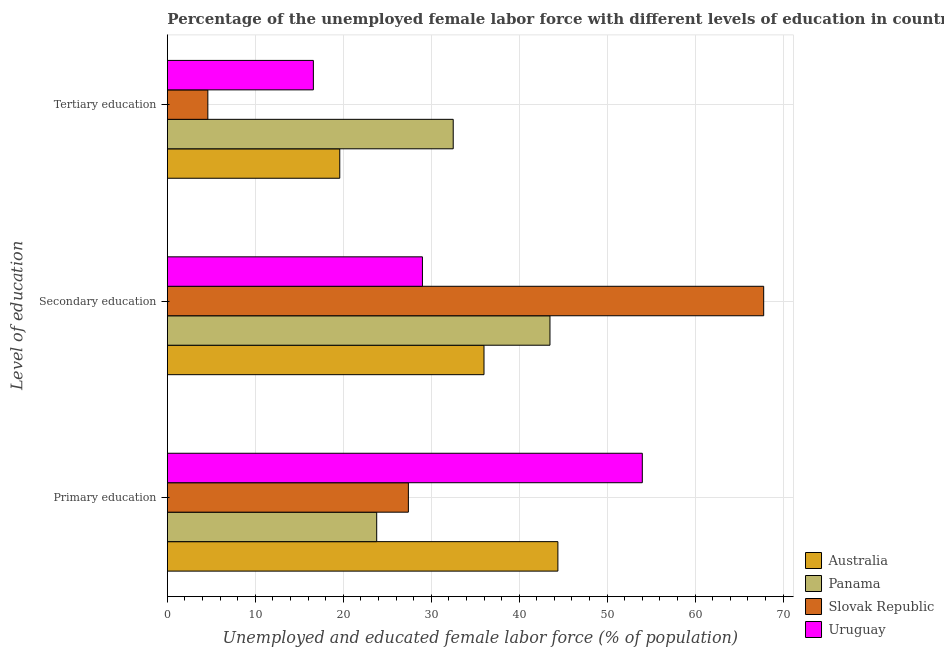How many groups of bars are there?
Offer a very short reply. 3. What is the label of the 2nd group of bars from the top?
Provide a short and direct response. Secondary education. What is the percentage of female labor force who received primary education in Australia?
Keep it short and to the point. 44.4. Across all countries, what is the maximum percentage of female labor force who received secondary education?
Give a very brief answer. 67.8. Across all countries, what is the minimum percentage of female labor force who received secondary education?
Give a very brief answer. 29. In which country was the percentage of female labor force who received secondary education maximum?
Offer a terse response. Slovak Republic. In which country was the percentage of female labor force who received tertiary education minimum?
Your answer should be very brief. Slovak Republic. What is the total percentage of female labor force who received tertiary education in the graph?
Provide a short and direct response. 73.3. What is the difference between the percentage of female labor force who received secondary education in Panama and that in Slovak Republic?
Your answer should be very brief. -24.3. What is the difference between the percentage of female labor force who received secondary education in Panama and the percentage of female labor force who received primary education in Slovak Republic?
Keep it short and to the point. 16.1. What is the average percentage of female labor force who received primary education per country?
Ensure brevity in your answer.  37.4. What is the ratio of the percentage of female labor force who received secondary education in Australia to that in Uruguay?
Give a very brief answer. 1.24. Is the percentage of female labor force who received tertiary education in Slovak Republic less than that in Australia?
Your answer should be compact. Yes. Is the difference between the percentage of female labor force who received tertiary education in Panama and Uruguay greater than the difference between the percentage of female labor force who received primary education in Panama and Uruguay?
Offer a terse response. Yes. What is the difference between the highest and the second highest percentage of female labor force who received tertiary education?
Give a very brief answer. 12.9. What is the difference between the highest and the lowest percentage of female labor force who received tertiary education?
Provide a short and direct response. 27.9. In how many countries, is the percentage of female labor force who received secondary education greater than the average percentage of female labor force who received secondary education taken over all countries?
Offer a terse response. 1. What does the 4th bar from the top in Tertiary education represents?
Offer a terse response. Australia. What does the 2nd bar from the bottom in Tertiary education represents?
Ensure brevity in your answer.  Panama. What is the difference between two consecutive major ticks on the X-axis?
Your answer should be very brief. 10. Are the values on the major ticks of X-axis written in scientific E-notation?
Your answer should be compact. No. Does the graph contain any zero values?
Your response must be concise. No. How many legend labels are there?
Provide a short and direct response. 4. How are the legend labels stacked?
Your response must be concise. Vertical. What is the title of the graph?
Keep it short and to the point. Percentage of the unemployed female labor force with different levels of education in countries. Does "Greece" appear as one of the legend labels in the graph?
Keep it short and to the point. No. What is the label or title of the X-axis?
Give a very brief answer. Unemployed and educated female labor force (% of population). What is the label or title of the Y-axis?
Offer a very short reply. Level of education. What is the Unemployed and educated female labor force (% of population) in Australia in Primary education?
Your answer should be very brief. 44.4. What is the Unemployed and educated female labor force (% of population) of Panama in Primary education?
Your answer should be very brief. 23.8. What is the Unemployed and educated female labor force (% of population) of Slovak Republic in Primary education?
Provide a short and direct response. 27.4. What is the Unemployed and educated female labor force (% of population) in Uruguay in Primary education?
Ensure brevity in your answer.  54. What is the Unemployed and educated female labor force (% of population) in Australia in Secondary education?
Your answer should be very brief. 36. What is the Unemployed and educated female labor force (% of population) of Panama in Secondary education?
Ensure brevity in your answer.  43.5. What is the Unemployed and educated female labor force (% of population) in Slovak Republic in Secondary education?
Offer a terse response. 67.8. What is the Unemployed and educated female labor force (% of population) in Australia in Tertiary education?
Ensure brevity in your answer.  19.6. What is the Unemployed and educated female labor force (% of population) in Panama in Tertiary education?
Give a very brief answer. 32.5. What is the Unemployed and educated female labor force (% of population) of Slovak Republic in Tertiary education?
Give a very brief answer. 4.6. What is the Unemployed and educated female labor force (% of population) of Uruguay in Tertiary education?
Make the answer very short. 16.6. Across all Level of education, what is the maximum Unemployed and educated female labor force (% of population) of Australia?
Your answer should be compact. 44.4. Across all Level of education, what is the maximum Unemployed and educated female labor force (% of population) of Panama?
Ensure brevity in your answer.  43.5. Across all Level of education, what is the maximum Unemployed and educated female labor force (% of population) of Slovak Republic?
Your answer should be compact. 67.8. Across all Level of education, what is the maximum Unemployed and educated female labor force (% of population) of Uruguay?
Provide a succinct answer. 54. Across all Level of education, what is the minimum Unemployed and educated female labor force (% of population) in Australia?
Offer a terse response. 19.6. Across all Level of education, what is the minimum Unemployed and educated female labor force (% of population) of Panama?
Your response must be concise. 23.8. Across all Level of education, what is the minimum Unemployed and educated female labor force (% of population) of Slovak Republic?
Keep it short and to the point. 4.6. Across all Level of education, what is the minimum Unemployed and educated female labor force (% of population) in Uruguay?
Your answer should be compact. 16.6. What is the total Unemployed and educated female labor force (% of population) in Australia in the graph?
Provide a short and direct response. 100. What is the total Unemployed and educated female labor force (% of population) in Panama in the graph?
Offer a very short reply. 99.8. What is the total Unemployed and educated female labor force (% of population) in Slovak Republic in the graph?
Provide a succinct answer. 99.8. What is the total Unemployed and educated female labor force (% of population) in Uruguay in the graph?
Your answer should be compact. 99.6. What is the difference between the Unemployed and educated female labor force (% of population) in Australia in Primary education and that in Secondary education?
Your answer should be compact. 8.4. What is the difference between the Unemployed and educated female labor force (% of population) in Panama in Primary education and that in Secondary education?
Provide a succinct answer. -19.7. What is the difference between the Unemployed and educated female labor force (% of population) in Slovak Republic in Primary education and that in Secondary education?
Give a very brief answer. -40.4. What is the difference between the Unemployed and educated female labor force (% of population) of Australia in Primary education and that in Tertiary education?
Offer a terse response. 24.8. What is the difference between the Unemployed and educated female labor force (% of population) of Slovak Republic in Primary education and that in Tertiary education?
Offer a very short reply. 22.8. What is the difference between the Unemployed and educated female labor force (% of population) of Uruguay in Primary education and that in Tertiary education?
Make the answer very short. 37.4. What is the difference between the Unemployed and educated female labor force (% of population) in Slovak Republic in Secondary education and that in Tertiary education?
Offer a terse response. 63.2. What is the difference between the Unemployed and educated female labor force (% of population) in Uruguay in Secondary education and that in Tertiary education?
Give a very brief answer. 12.4. What is the difference between the Unemployed and educated female labor force (% of population) in Australia in Primary education and the Unemployed and educated female labor force (% of population) in Slovak Republic in Secondary education?
Your answer should be compact. -23.4. What is the difference between the Unemployed and educated female labor force (% of population) in Australia in Primary education and the Unemployed and educated female labor force (% of population) in Uruguay in Secondary education?
Provide a short and direct response. 15.4. What is the difference between the Unemployed and educated female labor force (% of population) in Panama in Primary education and the Unemployed and educated female labor force (% of population) in Slovak Republic in Secondary education?
Provide a short and direct response. -44. What is the difference between the Unemployed and educated female labor force (% of population) of Slovak Republic in Primary education and the Unemployed and educated female labor force (% of population) of Uruguay in Secondary education?
Make the answer very short. -1.6. What is the difference between the Unemployed and educated female labor force (% of population) of Australia in Primary education and the Unemployed and educated female labor force (% of population) of Panama in Tertiary education?
Offer a terse response. 11.9. What is the difference between the Unemployed and educated female labor force (% of population) of Australia in Primary education and the Unemployed and educated female labor force (% of population) of Slovak Republic in Tertiary education?
Provide a succinct answer. 39.8. What is the difference between the Unemployed and educated female labor force (% of population) of Australia in Primary education and the Unemployed and educated female labor force (% of population) of Uruguay in Tertiary education?
Give a very brief answer. 27.8. What is the difference between the Unemployed and educated female labor force (% of population) in Panama in Primary education and the Unemployed and educated female labor force (% of population) in Slovak Republic in Tertiary education?
Offer a terse response. 19.2. What is the difference between the Unemployed and educated female labor force (% of population) of Panama in Primary education and the Unemployed and educated female labor force (% of population) of Uruguay in Tertiary education?
Your response must be concise. 7.2. What is the difference between the Unemployed and educated female labor force (% of population) in Slovak Republic in Primary education and the Unemployed and educated female labor force (% of population) in Uruguay in Tertiary education?
Provide a short and direct response. 10.8. What is the difference between the Unemployed and educated female labor force (% of population) of Australia in Secondary education and the Unemployed and educated female labor force (% of population) of Panama in Tertiary education?
Keep it short and to the point. 3.5. What is the difference between the Unemployed and educated female labor force (% of population) of Australia in Secondary education and the Unemployed and educated female labor force (% of population) of Slovak Republic in Tertiary education?
Keep it short and to the point. 31.4. What is the difference between the Unemployed and educated female labor force (% of population) of Panama in Secondary education and the Unemployed and educated female labor force (% of population) of Slovak Republic in Tertiary education?
Provide a short and direct response. 38.9. What is the difference between the Unemployed and educated female labor force (% of population) in Panama in Secondary education and the Unemployed and educated female labor force (% of population) in Uruguay in Tertiary education?
Offer a very short reply. 26.9. What is the difference between the Unemployed and educated female labor force (% of population) of Slovak Republic in Secondary education and the Unemployed and educated female labor force (% of population) of Uruguay in Tertiary education?
Your response must be concise. 51.2. What is the average Unemployed and educated female labor force (% of population) of Australia per Level of education?
Make the answer very short. 33.33. What is the average Unemployed and educated female labor force (% of population) of Panama per Level of education?
Provide a short and direct response. 33.27. What is the average Unemployed and educated female labor force (% of population) of Slovak Republic per Level of education?
Provide a short and direct response. 33.27. What is the average Unemployed and educated female labor force (% of population) in Uruguay per Level of education?
Your answer should be compact. 33.2. What is the difference between the Unemployed and educated female labor force (% of population) in Australia and Unemployed and educated female labor force (% of population) in Panama in Primary education?
Offer a terse response. 20.6. What is the difference between the Unemployed and educated female labor force (% of population) of Panama and Unemployed and educated female labor force (% of population) of Uruguay in Primary education?
Provide a short and direct response. -30.2. What is the difference between the Unemployed and educated female labor force (% of population) of Slovak Republic and Unemployed and educated female labor force (% of population) of Uruguay in Primary education?
Give a very brief answer. -26.6. What is the difference between the Unemployed and educated female labor force (% of population) of Australia and Unemployed and educated female labor force (% of population) of Panama in Secondary education?
Make the answer very short. -7.5. What is the difference between the Unemployed and educated female labor force (% of population) of Australia and Unemployed and educated female labor force (% of population) of Slovak Republic in Secondary education?
Provide a succinct answer. -31.8. What is the difference between the Unemployed and educated female labor force (% of population) in Panama and Unemployed and educated female labor force (% of population) in Slovak Republic in Secondary education?
Give a very brief answer. -24.3. What is the difference between the Unemployed and educated female labor force (% of population) of Panama and Unemployed and educated female labor force (% of population) of Uruguay in Secondary education?
Provide a short and direct response. 14.5. What is the difference between the Unemployed and educated female labor force (% of population) of Slovak Republic and Unemployed and educated female labor force (% of population) of Uruguay in Secondary education?
Provide a succinct answer. 38.8. What is the difference between the Unemployed and educated female labor force (% of population) of Australia and Unemployed and educated female labor force (% of population) of Slovak Republic in Tertiary education?
Offer a terse response. 15. What is the difference between the Unemployed and educated female labor force (% of population) in Australia and Unemployed and educated female labor force (% of population) in Uruguay in Tertiary education?
Provide a succinct answer. 3. What is the difference between the Unemployed and educated female labor force (% of population) of Panama and Unemployed and educated female labor force (% of population) of Slovak Republic in Tertiary education?
Give a very brief answer. 27.9. What is the ratio of the Unemployed and educated female labor force (% of population) in Australia in Primary education to that in Secondary education?
Provide a short and direct response. 1.23. What is the ratio of the Unemployed and educated female labor force (% of population) in Panama in Primary education to that in Secondary education?
Your answer should be very brief. 0.55. What is the ratio of the Unemployed and educated female labor force (% of population) in Slovak Republic in Primary education to that in Secondary education?
Your answer should be very brief. 0.4. What is the ratio of the Unemployed and educated female labor force (% of population) in Uruguay in Primary education to that in Secondary education?
Make the answer very short. 1.86. What is the ratio of the Unemployed and educated female labor force (% of population) of Australia in Primary education to that in Tertiary education?
Ensure brevity in your answer.  2.27. What is the ratio of the Unemployed and educated female labor force (% of population) of Panama in Primary education to that in Tertiary education?
Your response must be concise. 0.73. What is the ratio of the Unemployed and educated female labor force (% of population) of Slovak Republic in Primary education to that in Tertiary education?
Make the answer very short. 5.96. What is the ratio of the Unemployed and educated female labor force (% of population) in Uruguay in Primary education to that in Tertiary education?
Keep it short and to the point. 3.25. What is the ratio of the Unemployed and educated female labor force (% of population) of Australia in Secondary education to that in Tertiary education?
Give a very brief answer. 1.84. What is the ratio of the Unemployed and educated female labor force (% of population) in Panama in Secondary education to that in Tertiary education?
Give a very brief answer. 1.34. What is the ratio of the Unemployed and educated female labor force (% of population) of Slovak Republic in Secondary education to that in Tertiary education?
Ensure brevity in your answer.  14.74. What is the ratio of the Unemployed and educated female labor force (% of population) in Uruguay in Secondary education to that in Tertiary education?
Give a very brief answer. 1.75. What is the difference between the highest and the second highest Unemployed and educated female labor force (% of population) of Australia?
Ensure brevity in your answer.  8.4. What is the difference between the highest and the second highest Unemployed and educated female labor force (% of population) of Slovak Republic?
Keep it short and to the point. 40.4. What is the difference between the highest and the second highest Unemployed and educated female labor force (% of population) in Uruguay?
Ensure brevity in your answer.  25. What is the difference between the highest and the lowest Unemployed and educated female labor force (% of population) of Australia?
Provide a short and direct response. 24.8. What is the difference between the highest and the lowest Unemployed and educated female labor force (% of population) in Panama?
Provide a short and direct response. 19.7. What is the difference between the highest and the lowest Unemployed and educated female labor force (% of population) in Slovak Republic?
Provide a succinct answer. 63.2. What is the difference between the highest and the lowest Unemployed and educated female labor force (% of population) of Uruguay?
Ensure brevity in your answer.  37.4. 